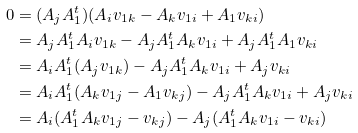Convert formula to latex. <formula><loc_0><loc_0><loc_500><loc_500>0 & = ( A _ { j } A _ { 1 } ^ { t } ) ( A _ { i } v _ { 1 k } - A _ { k } v _ { 1 i } + A _ { 1 } v _ { k i } ) \\ & = A _ { j } A _ { 1 } ^ { t } A _ { i } v _ { 1 k } - A _ { j } A _ { 1 } ^ { t } A _ { k } v _ { 1 i } + A _ { j } A _ { 1 } ^ { t } A _ { 1 } v _ { k i } \\ & = A _ { i } A _ { 1 } ^ { t } ( A _ { j } v _ { 1 k } ) - A _ { j } A _ { 1 } ^ { t } A _ { k } v _ { 1 i } + A _ { j } v _ { k i } \\ & = A _ { i } A _ { 1 } ^ { t } ( A _ { k } v _ { 1 j } - A _ { 1 } v _ { k j } ) - A _ { j } A _ { 1 } ^ { t } A _ { k } v _ { 1 i } + A _ { j } v _ { k i } \\ & = A _ { i } ( A _ { 1 } ^ { t } A _ { k } v _ { 1 j } - v _ { k j } ) - A _ { j } ( A _ { 1 } ^ { t } A _ { k } v _ { 1 i } - v _ { k i } )</formula> 